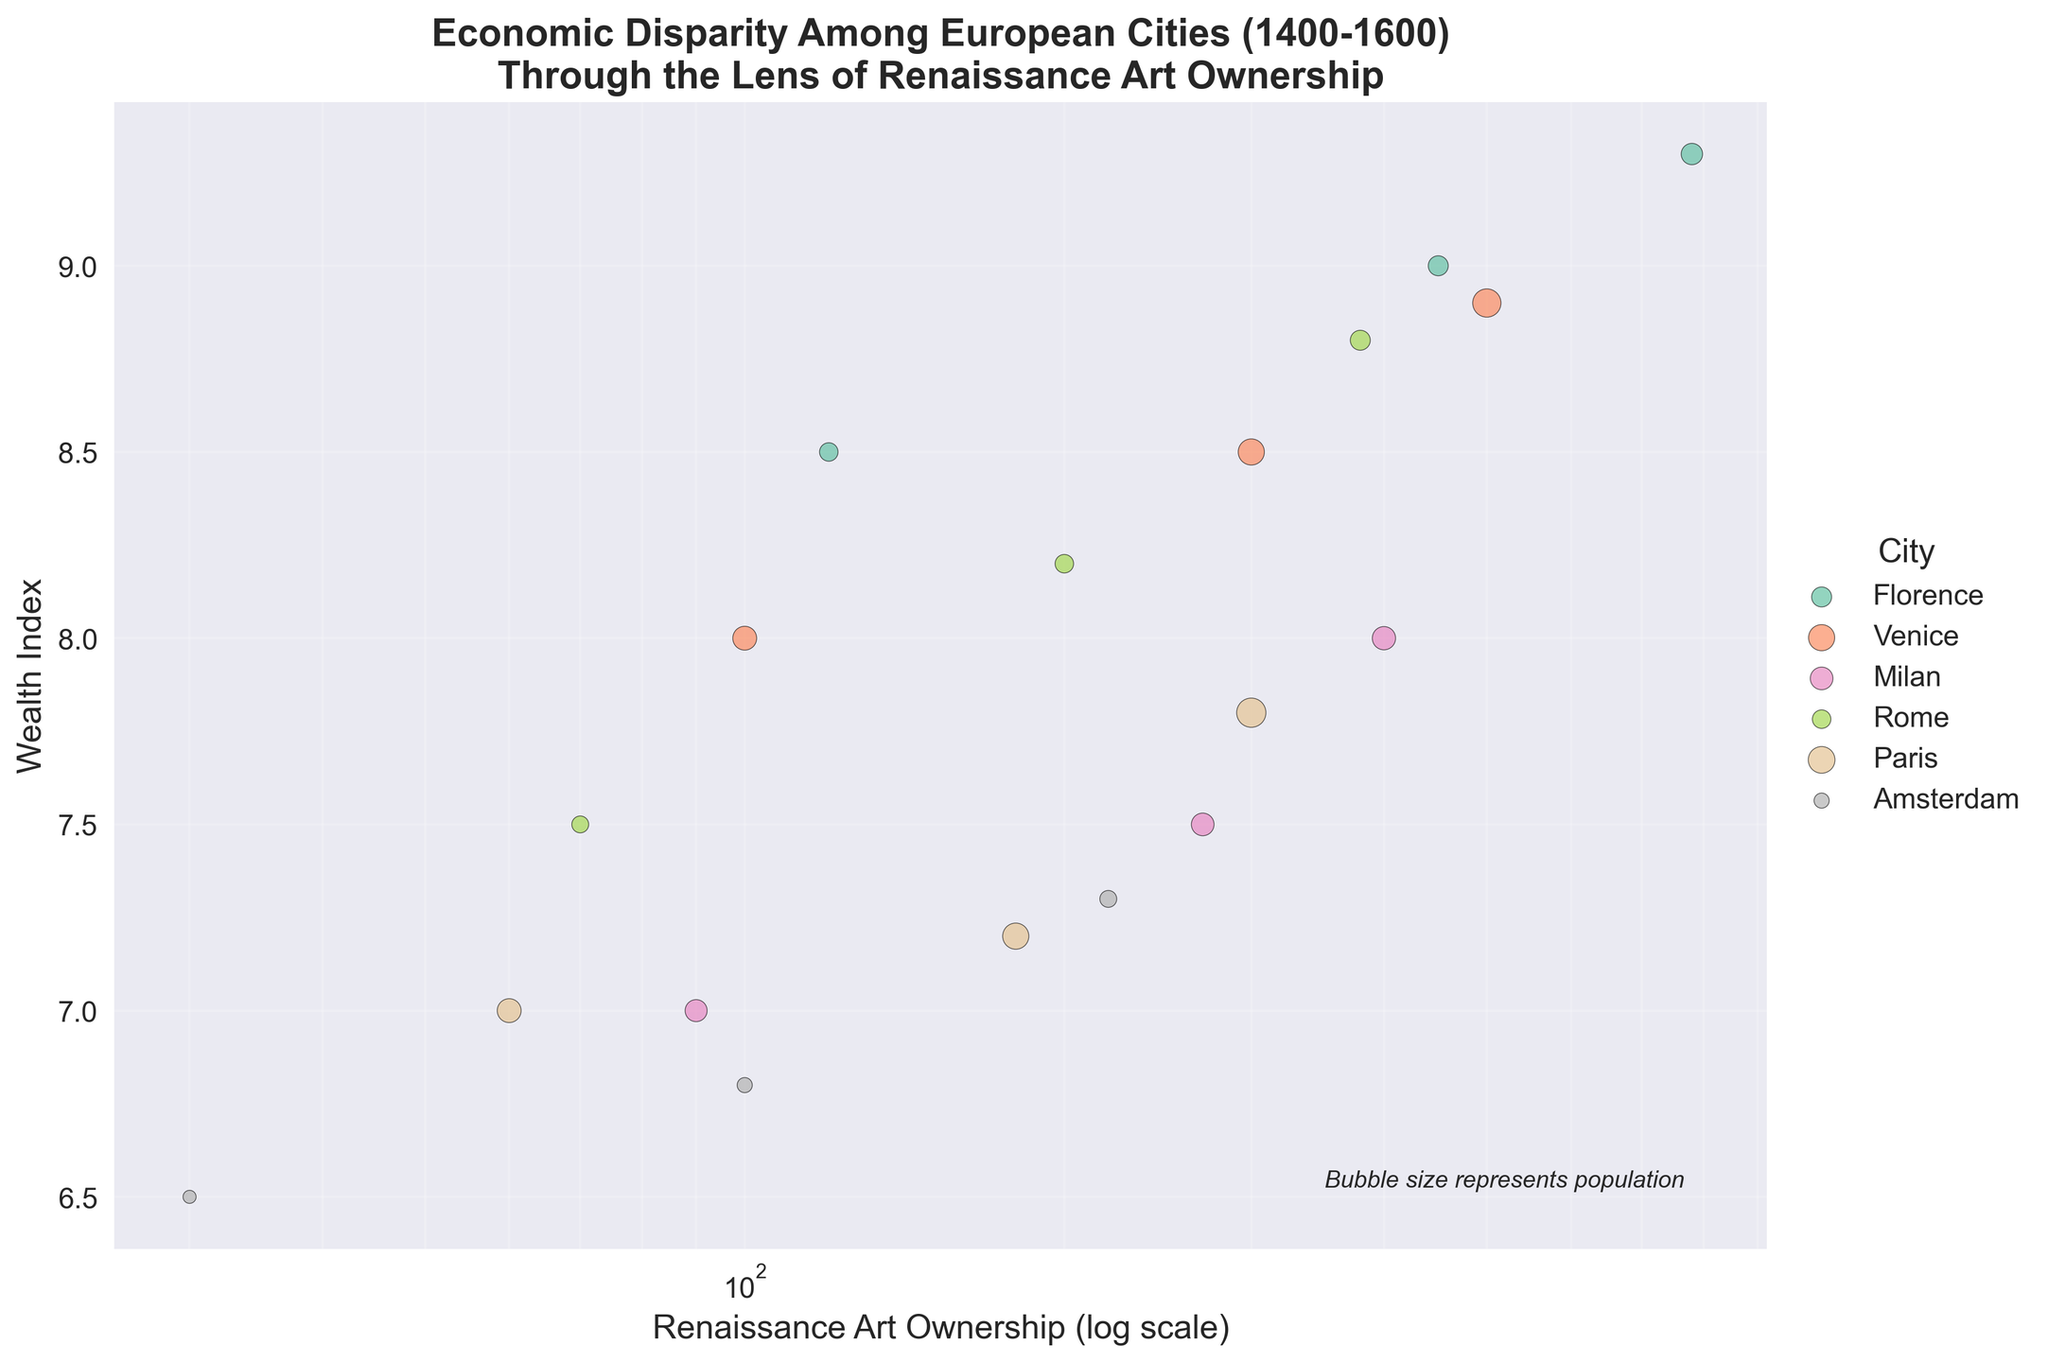what is the title of the figure? The title is written at the top of the figure. It reads, "Economic Disparity Among European Cities (1400-1600) Through the Lens of Renaissance Art Ownership".
Answer: Economic Disparity Among European Cities (1400-1600) Through the Lens of Renaissance Art Ownership What does the bubble size represent in the plot? The text at the bottom right corner of the plot indicates this information. It states, "Bubble size represents population".
Answer: population Which city had the highest Wealth Index in the year 1600? The data points for the year 1600 show that Florence has the highest Wealth Index value among the cities, as it is positioned at the top of the y-axis in that year.
Answer: Florence How does the Renaissance Art Ownership of Venice compare to Florence in 1500? On a logarithmic scale, Venice has a lower Renaissance Art Ownership value (300) compared to Florence (450), as the data point for Venice is to the left of Florence in 1500.
Answer: Venice has less Which city experienced the largest increase in Renaissance Art Ownership from 1400 to 1600? By comparing data points from 1400 and 1600, Florence shows the largest increase in Renaissance Art Ownership, moving from 120 to 780.
Answer: Florence What's the relationship between Renaissance Art Ownership and Wealth Index for Milan? The scatter points for Milan from 1400 to 1600 show a positive relationship. As Renaissance Art Ownership increases from 90 to 400, the Wealth Index also rises from 7.0 to 8.0.
Answer: Positive Relationship Which cities have Renaissance Art Ownership numbers exceeding 500 in 1600? The scatter points on the log scale for the year 1600 show that only Florence and Venice have Renaissance Art Ownership values exceeding 500.
Answer: Florence and Venice Between 1400 and 1600, which city has the smallest change in its Wealth Index? By checking the values for each city, Amsterdam has the smallest change in Wealth Index, from 6.5 in 1400 to 7.3 in 1600, a difference of 0.8.
Answer: Amsterdam What is the average Wealth Index of all cities in the year 1500? Summing the Wealth Index values of all cities in 1500: Florence (9.0), Venice (8.5), Milan (7.5), Rome (8.2), Paris (7.2), Amsterdam (6.8) gives a total of 47.2. Dividing by the number of cities (6) gives 7.87.
Answer: 7.87 Which city had the largest population in 1400 and what is its Wealth Index? The data points for 1400 show that Venice had the largest population (100,000) and its Wealth Index at that time was 8.0.
Answer: Venice, 8.0 